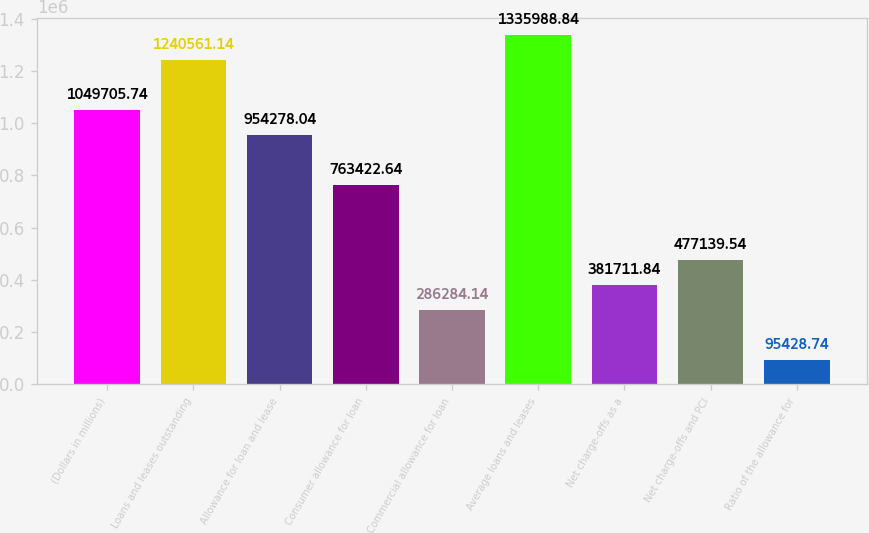Convert chart to OTSL. <chart><loc_0><loc_0><loc_500><loc_500><bar_chart><fcel>(Dollars in millions)<fcel>Loans and leases outstanding<fcel>Allowance for loan and lease<fcel>Consumer allowance for loan<fcel>Commercial allowance for loan<fcel>Average loans and leases<fcel>Net charge-offs as a<fcel>Net charge-offs and PCI<fcel>Ratio of the allowance for<nl><fcel>1.04971e+06<fcel>1.24056e+06<fcel>954278<fcel>763423<fcel>286284<fcel>1.33599e+06<fcel>381712<fcel>477140<fcel>95428.7<nl></chart> 